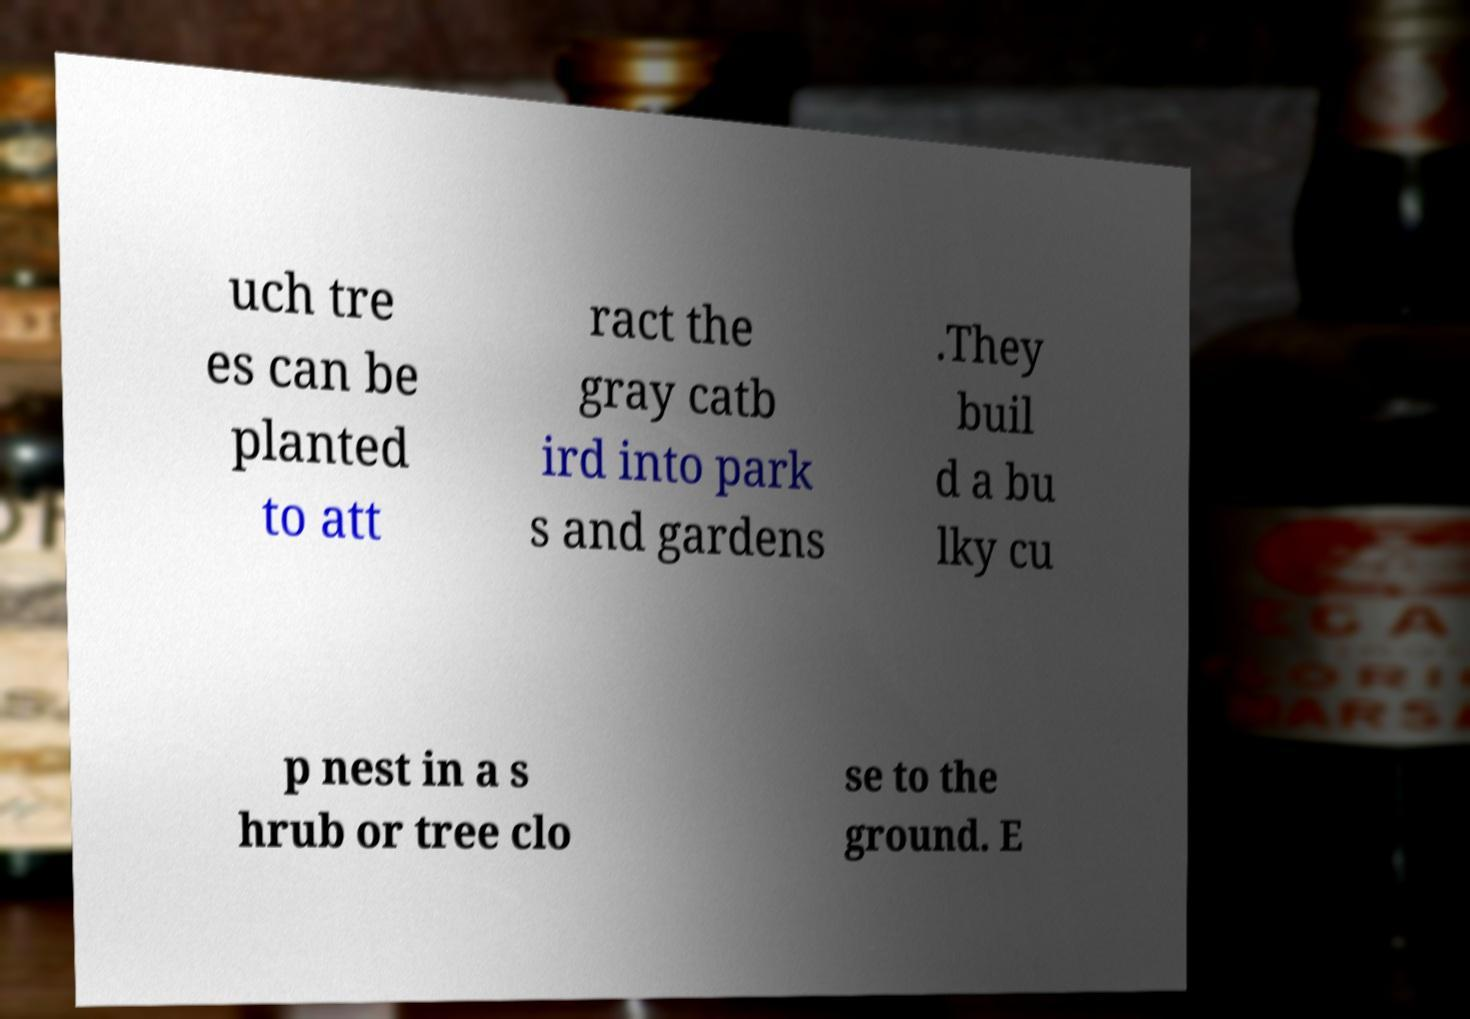Could you extract and type out the text from this image? uch tre es can be planted to att ract the gray catb ird into park s and gardens .They buil d a bu lky cu p nest in a s hrub or tree clo se to the ground. E 